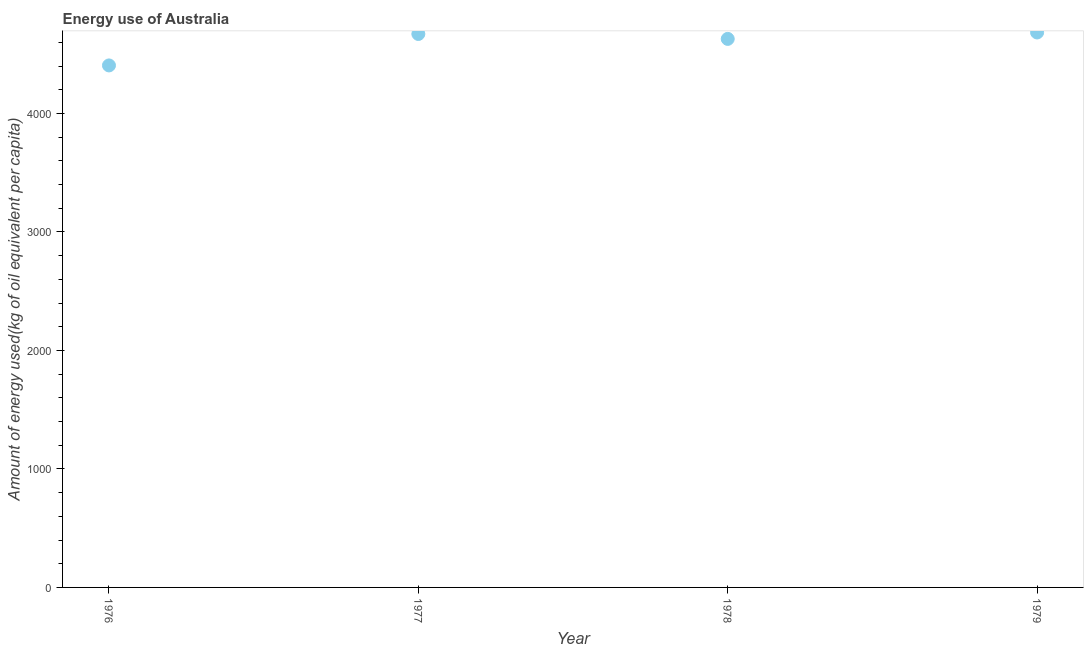What is the amount of energy used in 1978?
Offer a terse response. 4629.62. Across all years, what is the maximum amount of energy used?
Offer a very short reply. 4683.85. Across all years, what is the minimum amount of energy used?
Offer a terse response. 4405.7. In which year was the amount of energy used maximum?
Make the answer very short. 1979. In which year was the amount of energy used minimum?
Provide a succinct answer. 1976. What is the sum of the amount of energy used?
Keep it short and to the point. 1.84e+04. What is the difference between the amount of energy used in 1976 and 1977?
Provide a short and direct response. -265.49. What is the average amount of energy used per year?
Provide a short and direct response. 4597.59. What is the median amount of energy used?
Make the answer very short. 4650.41. In how many years, is the amount of energy used greater than 4000 kg?
Your response must be concise. 4. What is the ratio of the amount of energy used in 1977 to that in 1979?
Provide a short and direct response. 1. Is the amount of energy used in 1977 less than that in 1979?
Offer a very short reply. Yes. Is the difference between the amount of energy used in 1976 and 1979 greater than the difference between any two years?
Make the answer very short. Yes. What is the difference between the highest and the second highest amount of energy used?
Your answer should be very brief. 12.66. What is the difference between the highest and the lowest amount of energy used?
Provide a short and direct response. 278.15. Does the amount of energy used monotonically increase over the years?
Provide a succinct answer. No. What is the difference between two consecutive major ticks on the Y-axis?
Your answer should be very brief. 1000. Are the values on the major ticks of Y-axis written in scientific E-notation?
Make the answer very short. No. Does the graph contain any zero values?
Offer a terse response. No. What is the title of the graph?
Give a very brief answer. Energy use of Australia. What is the label or title of the X-axis?
Your answer should be compact. Year. What is the label or title of the Y-axis?
Your answer should be very brief. Amount of energy used(kg of oil equivalent per capita). What is the Amount of energy used(kg of oil equivalent per capita) in 1976?
Your response must be concise. 4405.7. What is the Amount of energy used(kg of oil equivalent per capita) in 1977?
Offer a very short reply. 4671.2. What is the Amount of energy used(kg of oil equivalent per capita) in 1978?
Provide a succinct answer. 4629.62. What is the Amount of energy used(kg of oil equivalent per capita) in 1979?
Offer a very short reply. 4683.85. What is the difference between the Amount of energy used(kg of oil equivalent per capita) in 1976 and 1977?
Offer a very short reply. -265.49. What is the difference between the Amount of energy used(kg of oil equivalent per capita) in 1976 and 1978?
Provide a succinct answer. -223.92. What is the difference between the Amount of energy used(kg of oil equivalent per capita) in 1976 and 1979?
Your answer should be very brief. -278.15. What is the difference between the Amount of energy used(kg of oil equivalent per capita) in 1977 and 1978?
Your answer should be very brief. 41.58. What is the difference between the Amount of energy used(kg of oil equivalent per capita) in 1977 and 1979?
Your answer should be compact. -12.66. What is the difference between the Amount of energy used(kg of oil equivalent per capita) in 1978 and 1979?
Your answer should be very brief. -54.23. What is the ratio of the Amount of energy used(kg of oil equivalent per capita) in 1976 to that in 1977?
Keep it short and to the point. 0.94. What is the ratio of the Amount of energy used(kg of oil equivalent per capita) in 1976 to that in 1979?
Provide a short and direct response. 0.94. What is the ratio of the Amount of energy used(kg of oil equivalent per capita) in 1977 to that in 1978?
Provide a short and direct response. 1.01. What is the ratio of the Amount of energy used(kg of oil equivalent per capita) in 1977 to that in 1979?
Offer a very short reply. 1. 